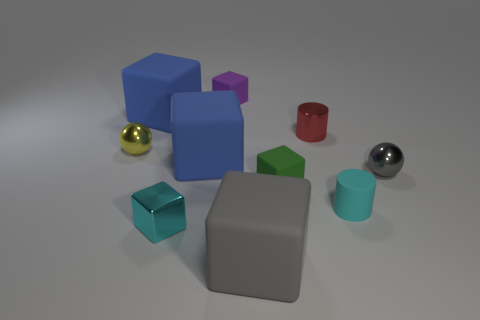Is the color of the metal cylinder the same as the small sphere on the left side of the small cyan shiny block?
Your answer should be compact. No. There is a rubber object that is both in front of the tiny green matte cube and behind the gray rubber thing; what shape is it?
Ensure brevity in your answer.  Cylinder. Is the number of tiny yellow cylinders less than the number of rubber objects?
Keep it short and to the point. Yes. Are there any gray spheres?
Make the answer very short. Yes. What number of other things are the same size as the green thing?
Ensure brevity in your answer.  6. Do the cyan block and the cylinder on the right side of the red shiny thing have the same material?
Keep it short and to the point. No. Are there the same number of big gray rubber objects right of the green block and tiny cyan blocks that are behind the tiny gray shiny sphere?
Your answer should be very brief. Yes. What is the small yellow thing made of?
Keep it short and to the point. Metal. What color is the shiny cube that is the same size as the gray metal ball?
Your response must be concise. Cyan. Are there any large rubber cubes that are on the right side of the tiny cyan object that is right of the small purple rubber object?
Provide a short and direct response. No. 